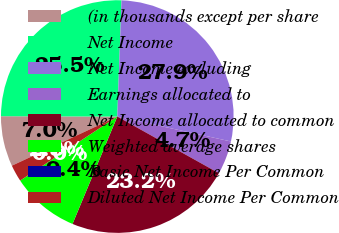<chart> <loc_0><loc_0><loc_500><loc_500><pie_chart><fcel>(in thousands except per share<fcel>Net Income<fcel>Net Income excluding<fcel>Earnings allocated to<fcel>Net Income allocated to common<fcel>Weighted average shares<fcel>Basic Net Income Per Common<fcel>Diluted Net Income Per Common<nl><fcel>6.99%<fcel>25.53%<fcel>27.86%<fcel>4.66%<fcel>23.2%<fcel>9.44%<fcel>0.0%<fcel>2.33%<nl></chart> 